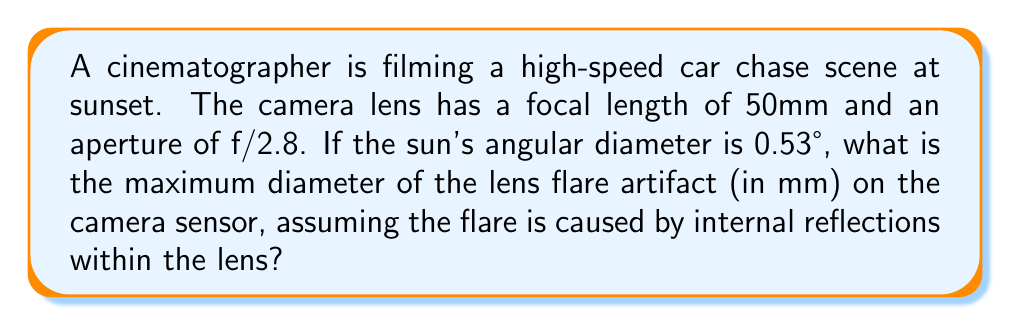What is the answer to this math problem? To solve this problem, we need to follow these steps:

1. Calculate the angle of view (AOV) of the lens:
   The AOV can be approximated using the formula:
   $$ AOV = 2 \arctan(\frac{d}{2f}) $$
   where $d$ is the sensor size (assuming a full-frame 35mm sensor, which is 36mm wide) and $f$ is the focal length.

   $$ AOV = 2 \arctan(\frac{36mm}{2 \cdot 50mm}) \approx 39.6° $$

2. Calculate the ratio of the sun's angular diameter to the AOV:
   $$ \text{Ratio} = \frac{0.53°}{39.6°} \approx 0.0134 $$

3. Calculate the size of the lens flare on the sensor:
   The maximum size of the flare will be proportional to the sensor size:
   $$ \text{Flare diameter} = 36mm \cdot 0.0134 \approx 0.48mm $$

4. Account for the aperture:
   The actual flare size can be affected by the aperture. A wider aperture (smaller f-number) allows more light and can potentially create larger flares. The f/2.8 aperture is relatively wide, so we can assume the calculated flare size is close to the maximum.

Therefore, the maximum diameter of the lens flare artifact on the camera sensor is approximately 0.48mm.
Answer: 0.48mm 